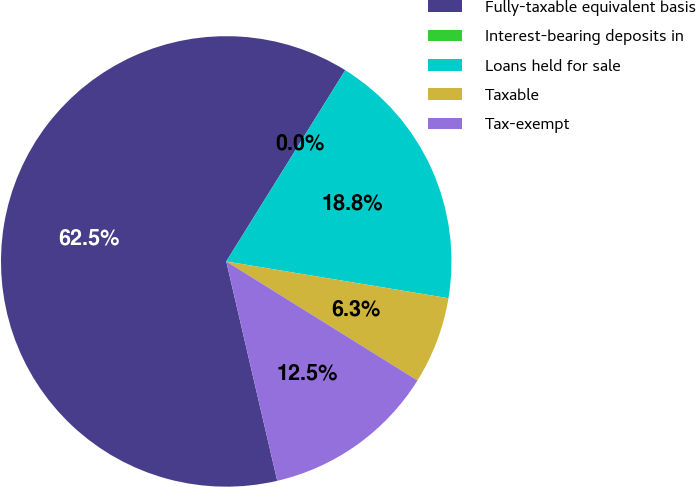<chart> <loc_0><loc_0><loc_500><loc_500><pie_chart><fcel>Fully-taxable equivalent basis<fcel>Interest-bearing deposits in<fcel>Loans held for sale<fcel>Taxable<fcel>Tax-exempt<nl><fcel>62.49%<fcel>0.0%<fcel>18.75%<fcel>6.25%<fcel>12.5%<nl></chart> 